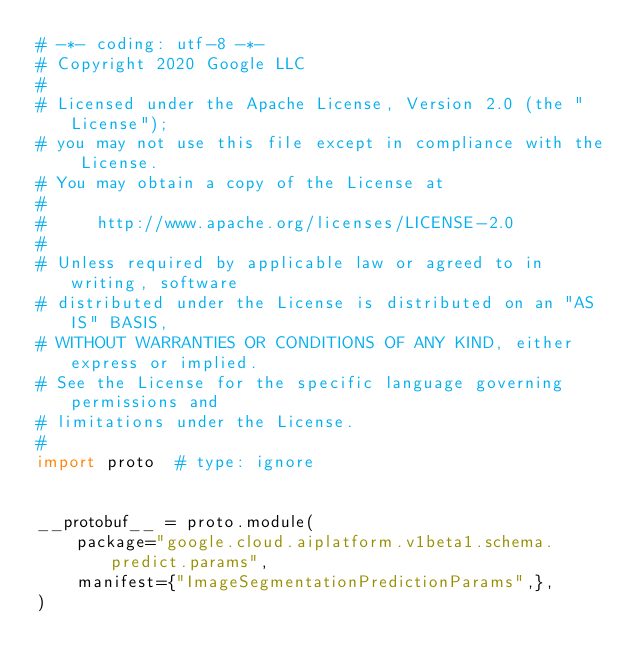<code> <loc_0><loc_0><loc_500><loc_500><_Python_># -*- coding: utf-8 -*-
# Copyright 2020 Google LLC
#
# Licensed under the Apache License, Version 2.0 (the "License");
# you may not use this file except in compliance with the License.
# You may obtain a copy of the License at
#
#     http://www.apache.org/licenses/LICENSE-2.0
#
# Unless required by applicable law or agreed to in writing, software
# distributed under the License is distributed on an "AS IS" BASIS,
# WITHOUT WARRANTIES OR CONDITIONS OF ANY KIND, either express or implied.
# See the License for the specific language governing permissions and
# limitations under the License.
#
import proto  # type: ignore


__protobuf__ = proto.module(
    package="google.cloud.aiplatform.v1beta1.schema.predict.params",
    manifest={"ImageSegmentationPredictionParams",},
)

</code> 